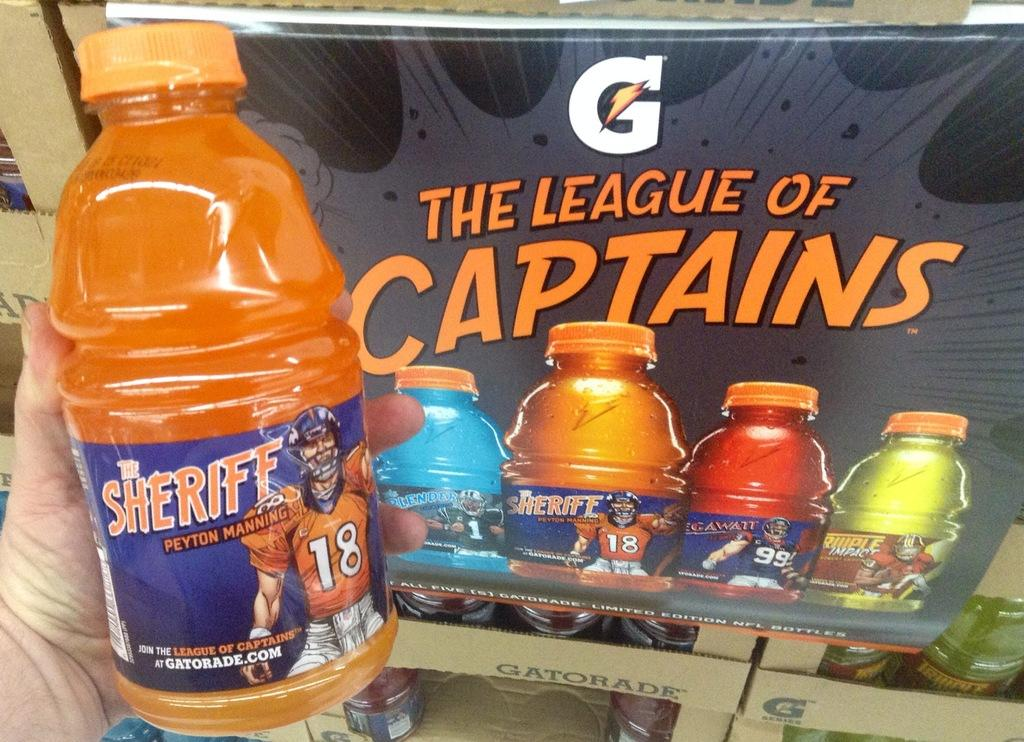<image>
Summarize the visual content of the image. A hand holds a bottle of orange Gatorade with a label that says The Sheriff on it, in front of a poster that says The League of Captains. 